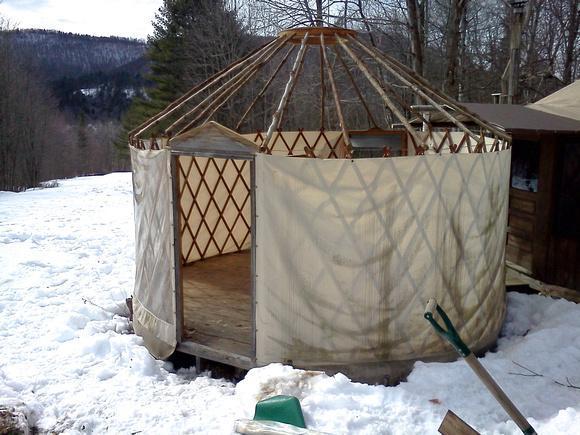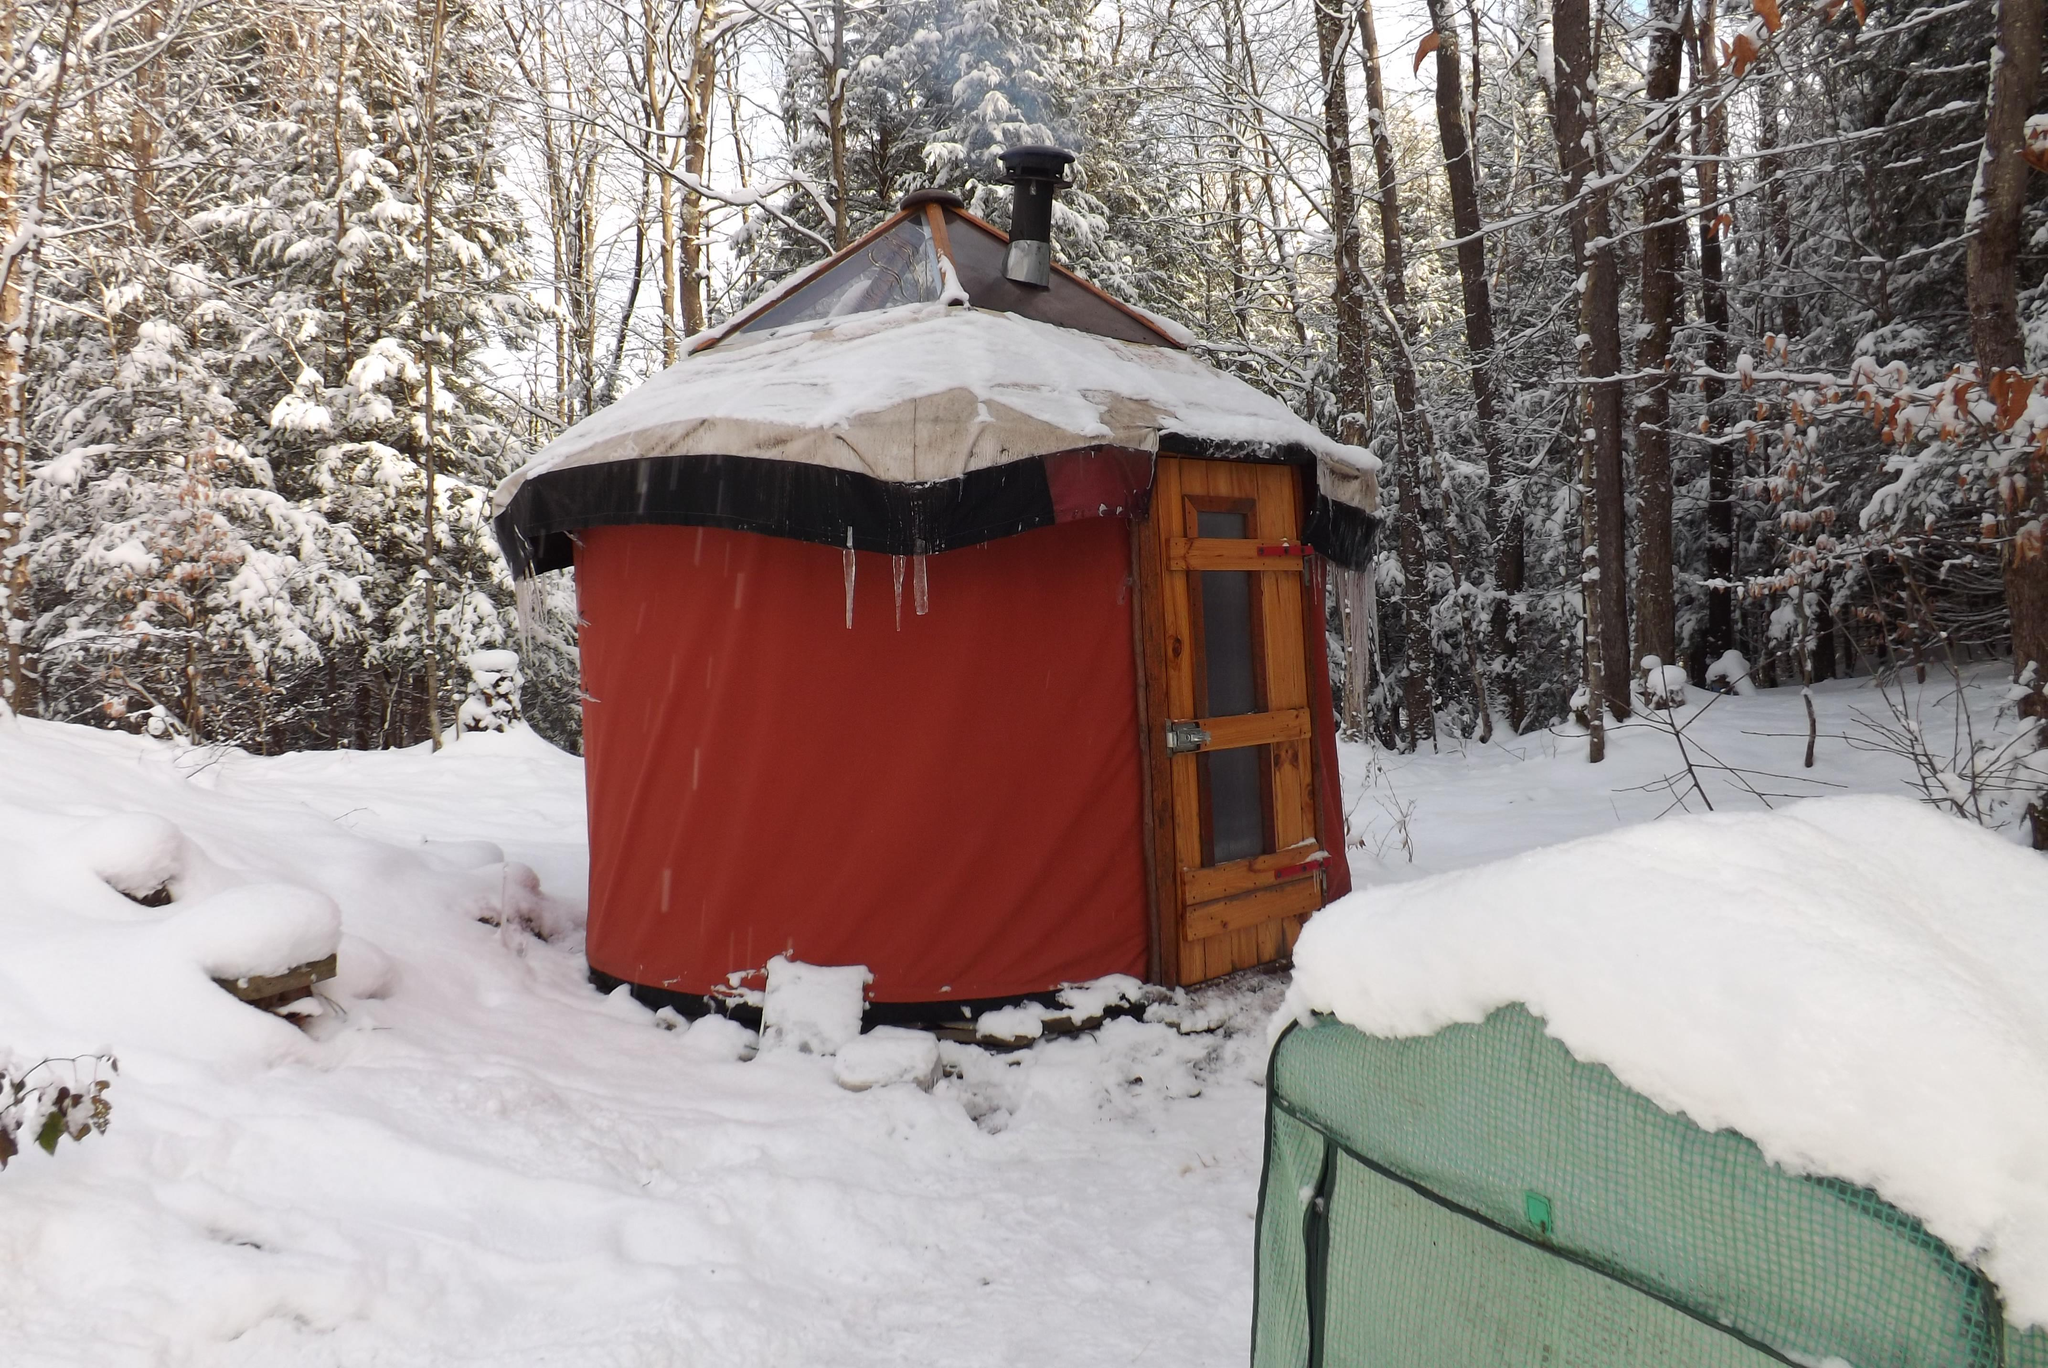The first image is the image on the left, the second image is the image on the right. Given the left and right images, does the statement "A white round house has a forward facing door and at least one window." hold true? Answer yes or no. No. The first image is the image on the left, the second image is the image on the right. Considering the images on both sides, is "There are stairs in the image on the left." valid? Answer yes or no. No. 